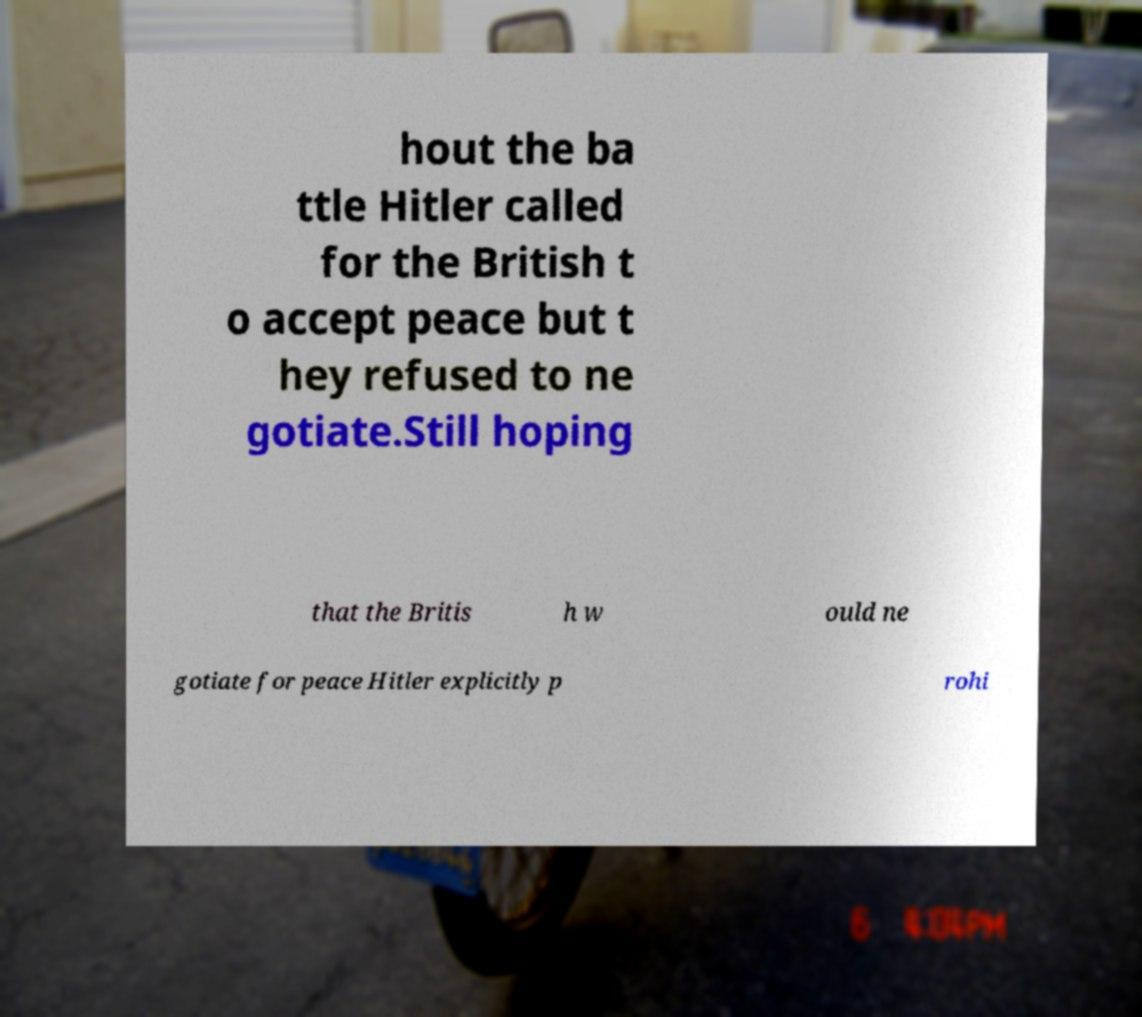What messages or text are displayed in this image? I need them in a readable, typed format. hout the ba ttle Hitler called for the British t o accept peace but t hey refused to ne gotiate.Still hoping that the Britis h w ould ne gotiate for peace Hitler explicitly p rohi 